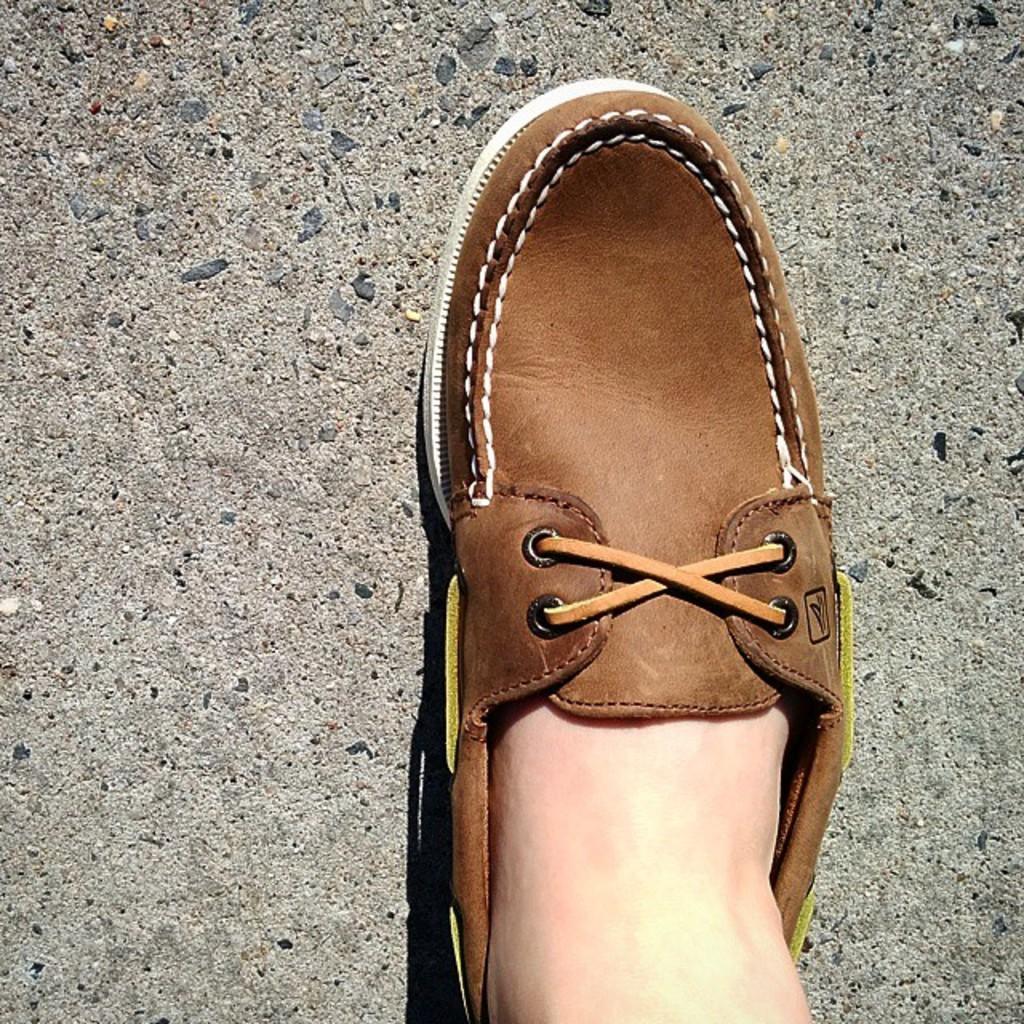Can you describe this image briefly? In this image we can see a person's leg with the shoe on the ground. 